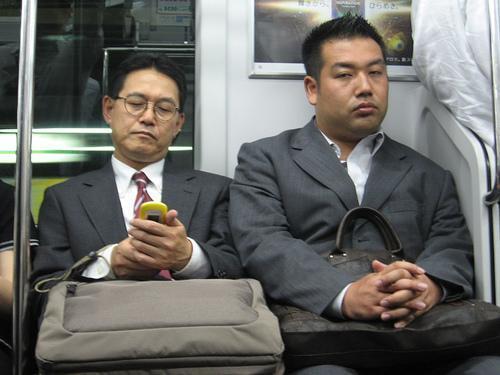How many trains are there?
Give a very brief answer. 1. How many handbags are there?
Give a very brief answer. 2. How many people can you see?
Give a very brief answer. 3. 